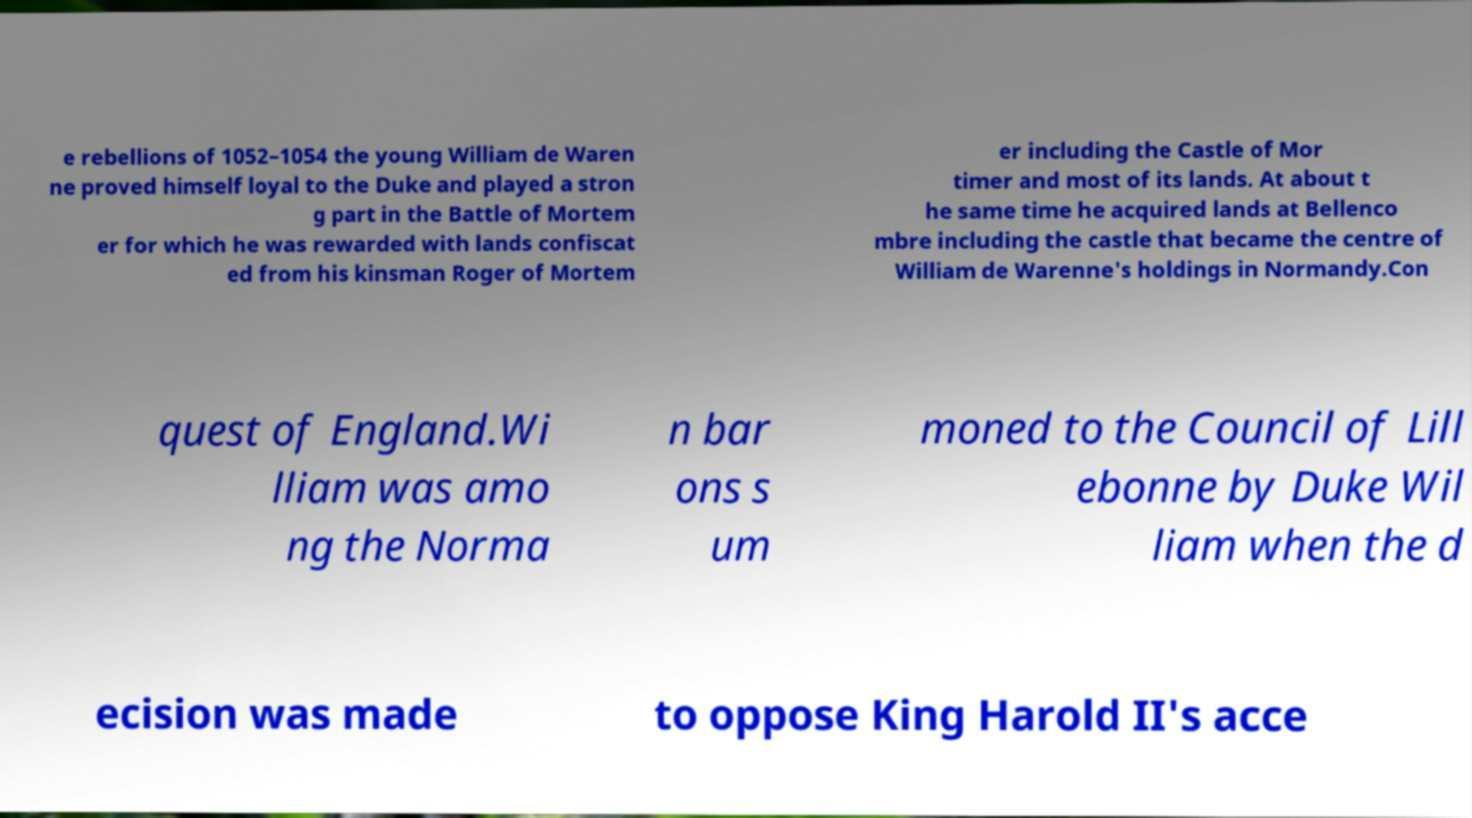Can you read and provide the text displayed in the image?This photo seems to have some interesting text. Can you extract and type it out for me? e rebellions of 1052–1054 the young William de Waren ne proved himself loyal to the Duke and played a stron g part in the Battle of Mortem er for which he was rewarded with lands confiscat ed from his kinsman Roger of Mortem er including the Castle of Mor timer and most of its lands. At about t he same time he acquired lands at Bellenco mbre including the castle that became the centre of William de Warenne's holdings in Normandy.Con quest of England.Wi lliam was amo ng the Norma n bar ons s um moned to the Council of Lill ebonne by Duke Wil liam when the d ecision was made to oppose King Harold II's acce 